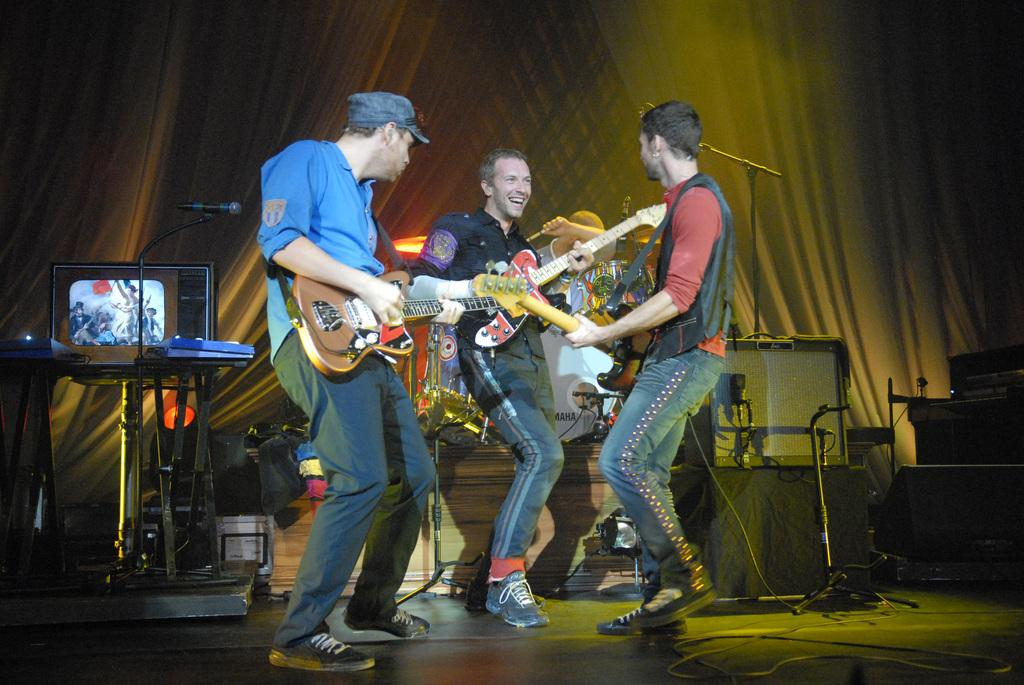How many people are in the image? There are three persons in the image. What are the persons doing in the image? The persons are standing and holding guitars. What other objects can be seen in the image besides the persons and guitars? There is a television on a table, a microphone with a microphone stand, focus lights, and speakers in the image. Can you tell me how much friction the microphone stand is experiencing in the image? There is no information about friction in the image, as it focuses on the persons, guitars, and other objects. --- Facts: 1. There is a person sitting on a chair in the image. 2. The person is holding a book. 3. There is a table next to the chair. 4. There is a lamp on the table. 5. The background of the image is a wall. Absurd Topics: parrot, ocean, trampoline Conversation: What is the person in the image doing? The person is sitting on a chair in the image. What object is the person holding? The person is holding a book. What is located next to the chair? There is a table next to the chair. What object is on the table? There is a lamp on the table. What can be seen behind the person? The background of the image is a wall. Reasoning: Let's think step by step in order to produce the conversation. We start by identifying the main subject in the image, which is the person sitting on a chair. Then, we describe what the person is doing, which is holding a book. Next, we expand the conversation to include other objects that are also visible, such as the table, lamp, and the wall in the background. Each question is designed to elicit a specific detail about the image that is known from the provided facts. Absurd Question/Answer: Can you tell me how many parrots are sitting on the trampoline in the image? There are no parrots or trampolines present in the image. 